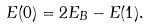<formula> <loc_0><loc_0><loc_500><loc_500>E ( 0 ) = 2 E _ { B } - E ( 1 ) .</formula> 